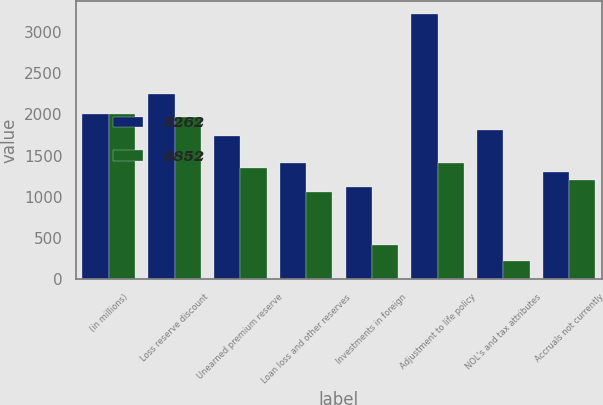Convert chart. <chart><loc_0><loc_0><loc_500><loc_500><stacked_bar_chart><ecel><fcel>(in millions)<fcel>Loss reserve discount<fcel>Unearned premium reserve<fcel>Loan loss and other reserves<fcel>Investments in foreign<fcel>Adjustment to life policy<fcel>NOL's and tax attributes<fcel>Accruals not currently<nl><fcel>5262<fcel>2007<fcel>2249<fcel>1743<fcel>1408<fcel>1121<fcel>3213<fcel>1814<fcel>1305<nl><fcel>8852<fcel>2006<fcel>1969<fcel>1352<fcel>1054<fcel>420<fcel>1408<fcel>222<fcel>1209<nl></chart> 